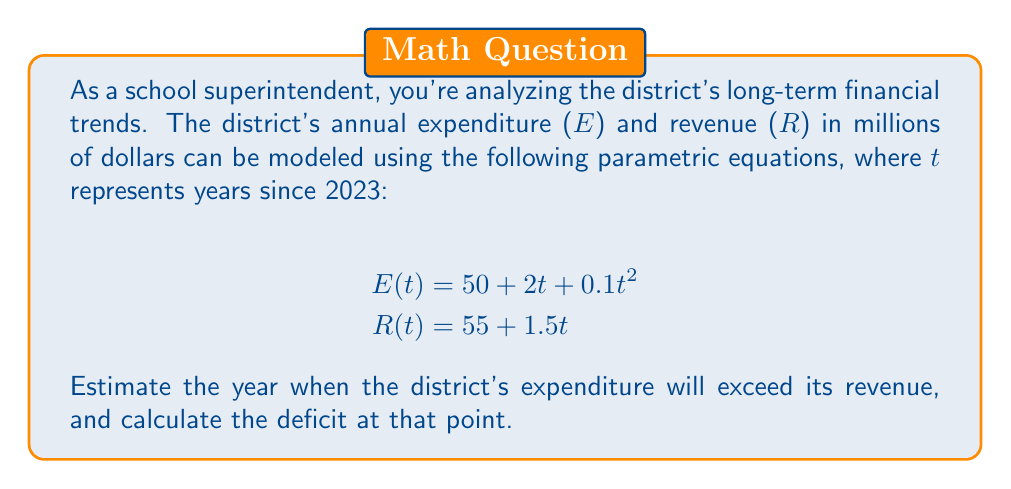Show me your answer to this math problem. To solve this problem, we need to follow these steps:

1) First, we need to find when expenditure equals revenue:
   $$E(t) = R(t)$$
   $$50 + 2t + 0.1t^2 = 55 + 1.5t$$

2) Rearrange the equation:
   $$0.1t^2 + 0.5t - 5 = 0$$

3) This is a quadratic equation. We can solve it using the quadratic formula:
   $$t = \frac{-b \pm \sqrt{b^2 - 4ac}}{2a}$$
   where $a = 0.1$, $b = 0.5$, and $c = -5$

4) Plugging in these values:
   $$t = \frac{-0.5 \pm \sqrt{0.5^2 - 4(0.1)(-5)}}{2(0.1)}$$
   $$= \frac{-0.5 \pm \sqrt{0.25 + 2}}{0.2}$$
   $$= \frac{-0.5 \pm \sqrt{2.25}}{0.2}$$
   $$= \frac{-0.5 \pm 1.5}{0.2}$$

5) This gives us two solutions:
   $$t_1 = \frac{-0.5 + 1.5}{0.2} = 5$$
   $$t_2 = \frac{-0.5 - 1.5}{0.2} = -10$$

   Since we're looking at future trends, we'll use the positive solution, $t = 5$.

6) This means expenditure will exceed revenue 5 years after 2023, which is 2028.

7) To calculate the deficit at this point, we need to compute E(5) and R(5):
   $$E(5) = 50 + 2(5) + 0.1(5^2) = 60 + 2.5 = 62.5$$
   $$R(5) = 55 + 1.5(5) = 62.5$$

8) The deficit at this point is $E(5) - R(5) = 62.5 - 62.5 = 0$.

However, to find when there's an actual deficit, we need to look at the next year:
   $$E(6) = 50 + 2(6) + 0.1(6^2) = 62 + 3.6 = 65.6$$
   $$R(6) = 55 + 1.5(6) = 64$$

The deficit in 2029 (6 years after 2023) will be $65.6 - 64 = 1.6$ million dollars.
Answer: Expenditure will exceed revenue in 2028 (5 years after 2023). The first deficit will occur in 2029, with a deficit of $1.6 million. 